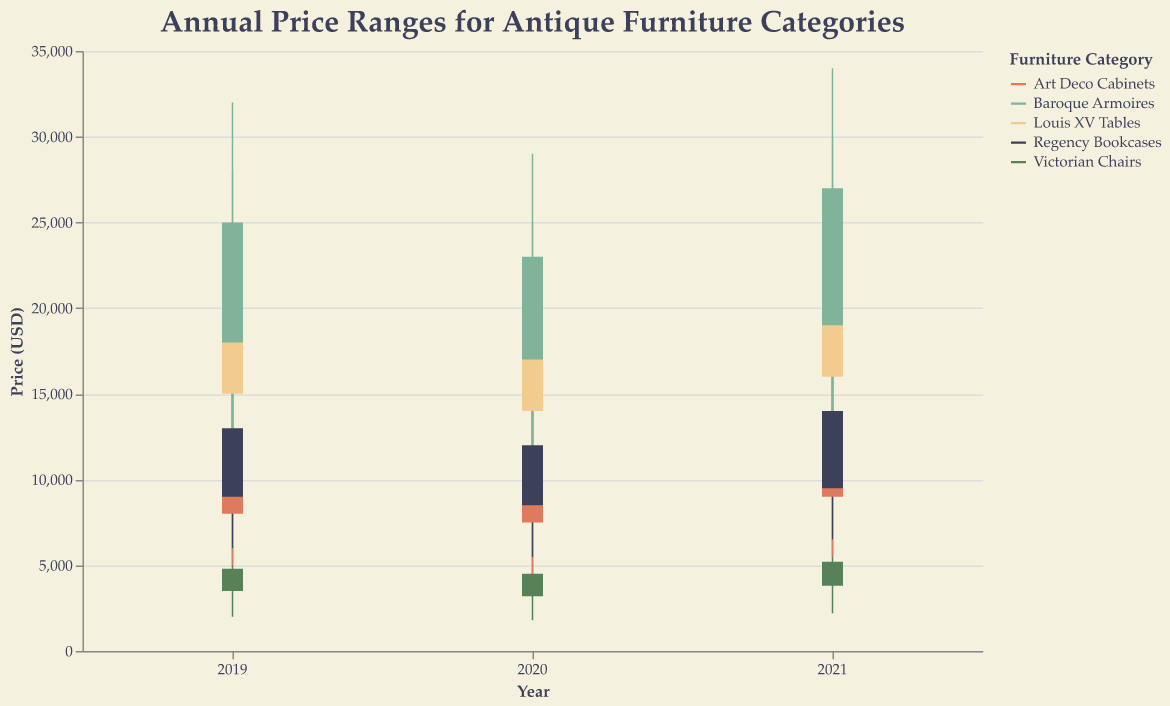What is the highest price for Baroque Armoires in 2021? Locate the "Baroque Armoires" category for the year 2021 and check the "High" value, which is the peak price reached that year.
Answer: 34,000 USD Which category had the lowest price in 2020? Examine the "Low" values for each category in 2020. Compare them to find the smallest price.
Answer: Victorian Chairs What is the average closing price of Louis XV Tables over the three years? Add the "Close" values for Louis XV Tables from 2019, 2020, and 2021, then divide by 3: (22,000 + 20,000 + 24,000) / 3
Answer: 22,000 USD How much did the highest price of Regency Bookcases increase from 2019 to 2021? Subtract the "High" value in 2019 from the "High" value in 2021 for Regency Bookcases: 17,000 - 16,000
Answer: 1,000 USD Which furniture category has the narrowest price range in 2021? Calculate the price range for each category in 2021 by subtracting the "Low" value from the "High" value, and find the smallest range.
Answer: Art Deco Cabinets What is the difference between the opening price of Art Deco Cabinets in 2019 and 2020? Subtract the "Open" price of Art Deco Cabinets in 2020 from the "Open" price in 2019: 8,000 - 7,500
Answer: 500 USD Which category had the most significant price increase in closing value from 2020 to 2021? Calculate the difference in "Close" values from 2020 to 2021 for all categories and compare them to find the largest increase.
Answer: Baroque Armoires What is the total high value for Victorian Chairs over the three years combined? Sum the "High" values for Victorian Chairs from 2019, 2020, and 2021: 6,000 + 5,500 + 6,500
Answer: 18,000 USD Did any category have the same low value in consecutive years? Check the "Low" values for each category across consecutive years to find any matching values.
Answer: No What is the average high price for all categories in 2019? Add the "High" values for all categories in 2019 and then divide by the number of categories: (6,000 + 15,000 + 28,000 + 16,000 + 32,000) / 5
Answer: 19,400 USD 